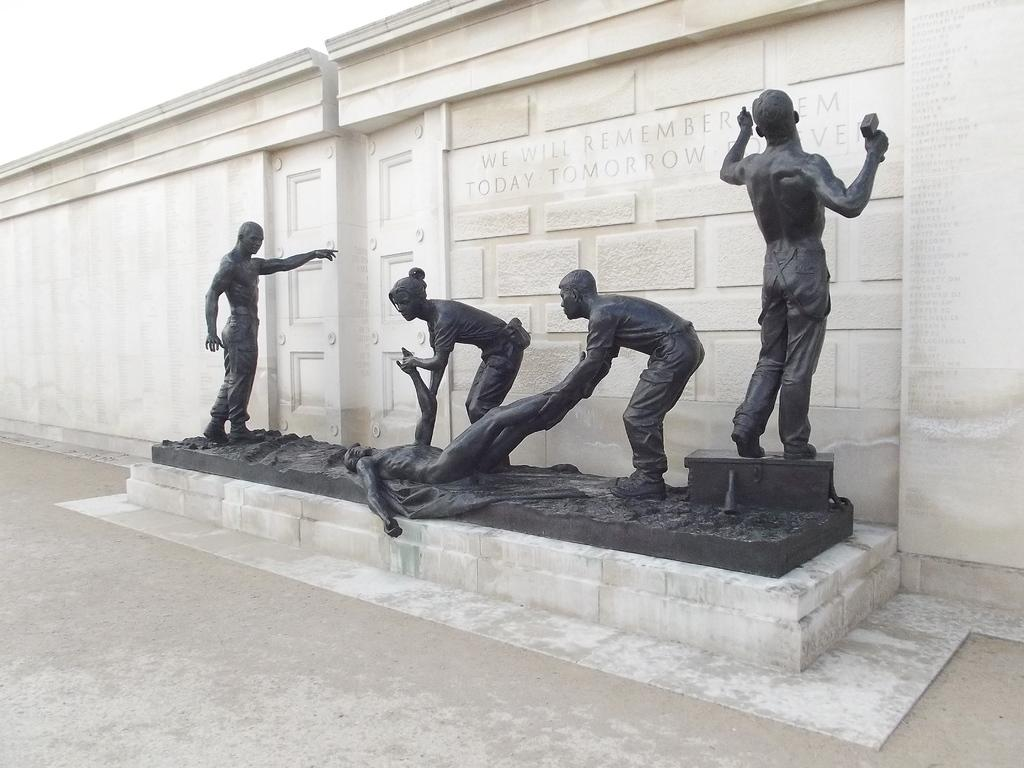What type of objects can be seen in the image? There are statues in the image. What is the color of the statues? The statues are black in color. What is visible in the background of the image? There is a wall and the sky visible in the background of the image. What time does the clock show in the image? There is no clock present in the image. What type of food can be eaten with a fork in the image? There is no fork present in the image. 